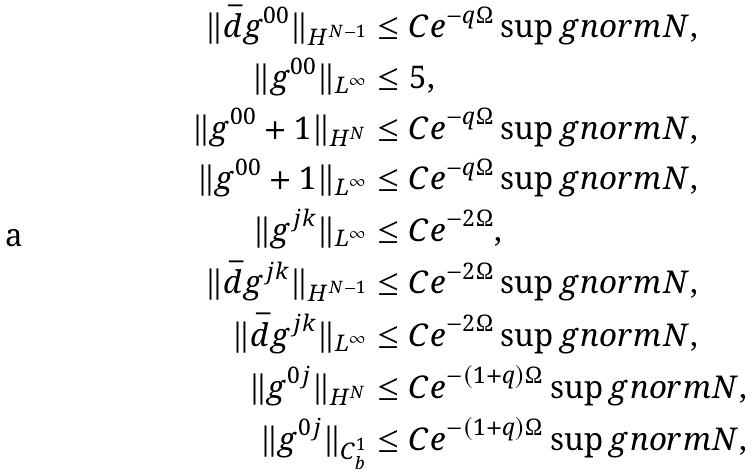<formula> <loc_0><loc_0><loc_500><loc_500>\| \bar { d } g ^ { 0 0 } \| _ { H ^ { N - 1 } } & \leq C e ^ { - q \Omega } \sup g n o r m { N } , \\ \| g ^ { 0 0 } \| _ { L ^ { \infty } } & \leq 5 , \\ \| g ^ { 0 0 } + 1 \| _ { H ^ { N } } & \leq C e ^ { - q \Omega } \sup g n o r m { N } , \\ \| g ^ { 0 0 } + 1 \| _ { L ^ { \infty } } & \leq C e ^ { - q \Omega } \sup g n o r m { N } , \\ \| g ^ { j k } \| _ { L ^ { \infty } } & \leq C e ^ { - 2 \Omega } , \\ \| \bar { d } g ^ { j k } \| _ { H ^ { N - 1 } } & \leq C e ^ { - 2 \Omega } \sup g n o r m { N } , \\ \| \bar { d } g ^ { j k } \| _ { L ^ { \infty } } & \leq C e ^ { - 2 \Omega } \sup g n o r m { N } , \\ \| g ^ { 0 j } \| _ { H ^ { N } } & \leq C e ^ { - ( 1 + q ) \Omega } \sup g n o r m { N } , \\ \| g ^ { 0 j } \| _ { C _ { b } ^ { 1 } } & \leq C e ^ { - ( 1 + q ) \Omega } \sup g n o r m { N } ,</formula> 